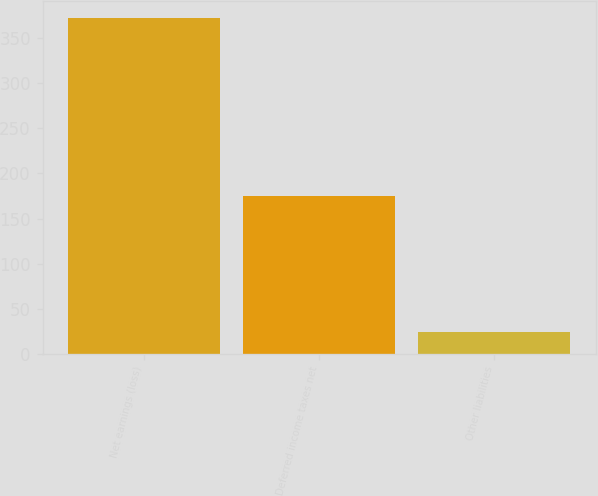Convert chart to OTSL. <chart><loc_0><loc_0><loc_500><loc_500><bar_chart><fcel>Net earnings (loss)<fcel>Deferred income taxes net<fcel>Other liabilities<nl><fcel>372<fcel>175<fcel>24<nl></chart> 